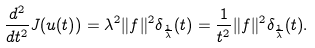<formula> <loc_0><loc_0><loc_500><loc_500>\frac { d ^ { 2 } } { d t ^ { 2 } } J ( u ( t ) ) = \lambda ^ { 2 } \| f \| ^ { 2 } \delta _ { \frac { 1 } \lambda } ( t ) = \frac { 1 } { t ^ { 2 } } \| f \| ^ { 2 } \delta _ { \frac { 1 } \lambda } ( t ) .</formula> 